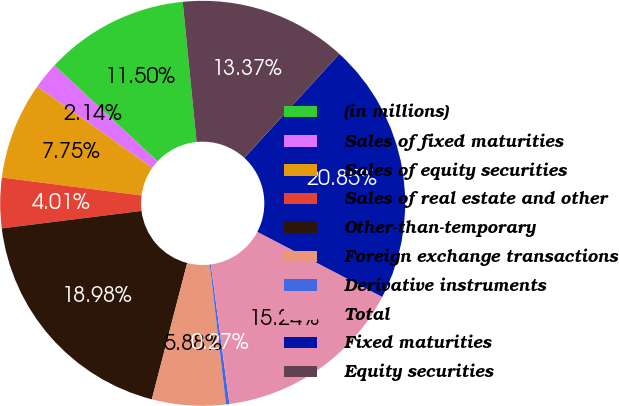Convert chart to OTSL. <chart><loc_0><loc_0><loc_500><loc_500><pie_chart><fcel>(in millions)<fcel>Sales of fixed maturities<fcel>Sales of equity securities<fcel>Sales of real estate and other<fcel>Other-than-temporary<fcel>Foreign exchange transactions<fcel>Derivative instruments<fcel>Total<fcel>Fixed maturities<fcel>Equity securities<nl><fcel>11.5%<fcel>2.14%<fcel>7.75%<fcel>4.01%<fcel>18.98%<fcel>5.88%<fcel>0.27%<fcel>15.24%<fcel>20.85%<fcel>13.37%<nl></chart> 